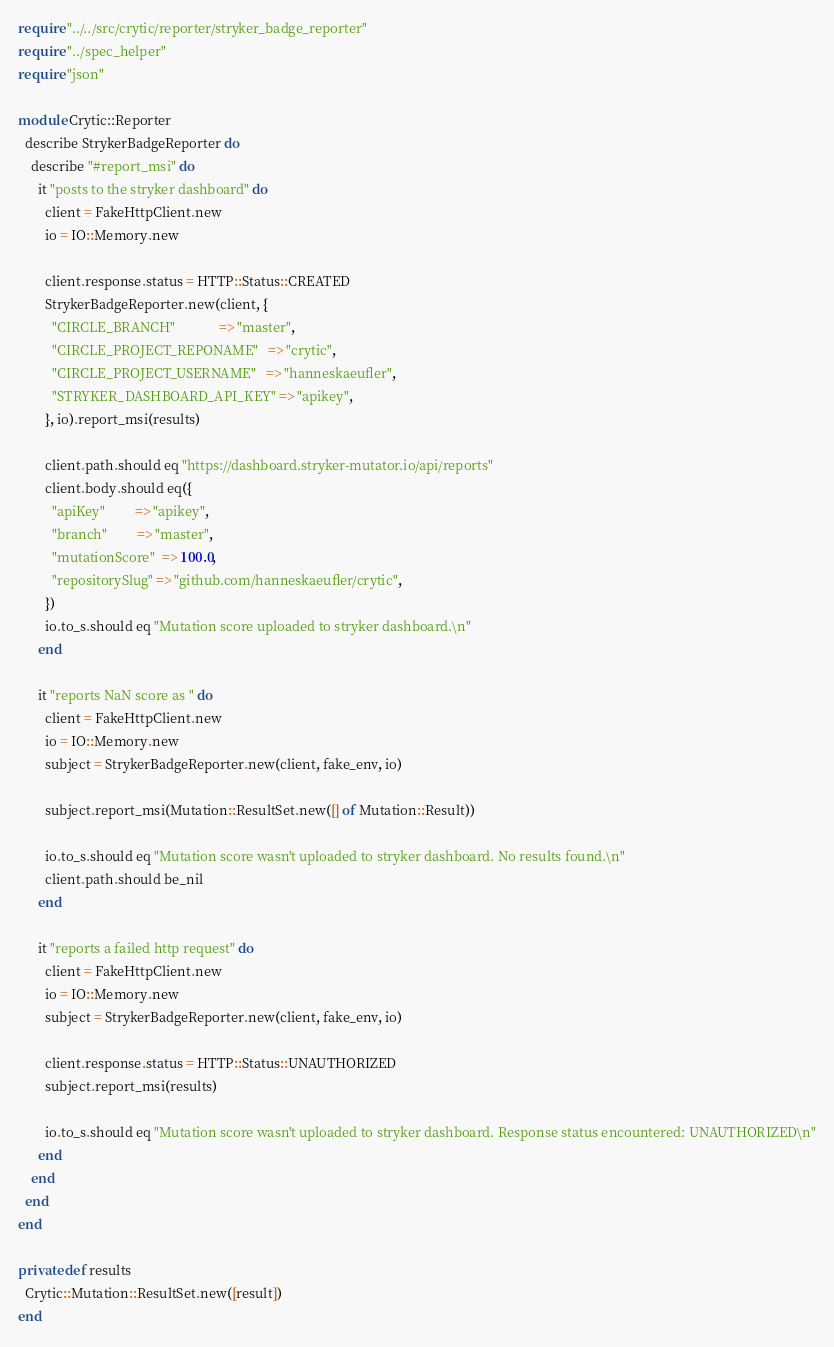<code> <loc_0><loc_0><loc_500><loc_500><_Crystal_>require "../../src/crytic/reporter/stryker_badge_reporter"
require "../spec_helper"
require "json"

module Crytic::Reporter
  describe StrykerBadgeReporter do
    describe "#report_msi" do
      it "posts to the stryker dashboard" do
        client = FakeHttpClient.new
        io = IO::Memory.new

        client.response.status = HTTP::Status::CREATED
        StrykerBadgeReporter.new(client, {
          "CIRCLE_BRANCH"             => "master",
          "CIRCLE_PROJECT_REPONAME"   => "crytic",
          "CIRCLE_PROJECT_USERNAME"   => "hanneskaeufler",
          "STRYKER_DASHBOARD_API_KEY" => "apikey",
        }, io).report_msi(results)

        client.path.should eq "https://dashboard.stryker-mutator.io/api/reports"
        client.body.should eq({
          "apiKey"         => "apikey",
          "branch"         => "master",
          "mutationScore"  => 100.0,
          "repositorySlug" => "github.com/hanneskaeufler/crytic",
        })
        io.to_s.should eq "Mutation score uploaded to stryker dashboard.\n"
      end

      it "reports NaN score as " do
        client = FakeHttpClient.new
        io = IO::Memory.new
        subject = StrykerBadgeReporter.new(client, fake_env, io)

        subject.report_msi(Mutation::ResultSet.new([] of Mutation::Result))

        io.to_s.should eq "Mutation score wasn't uploaded to stryker dashboard. No results found.\n"
        client.path.should be_nil
      end

      it "reports a failed http request" do
        client = FakeHttpClient.new
        io = IO::Memory.new
        subject = StrykerBadgeReporter.new(client, fake_env, io)

        client.response.status = HTTP::Status::UNAUTHORIZED
        subject.report_msi(results)

        io.to_s.should eq "Mutation score wasn't uploaded to stryker dashboard. Response status encountered: UNAUTHORIZED\n"
      end
    end
  end
end

private def results
  Crytic::Mutation::ResultSet.new([result])
end
</code> 